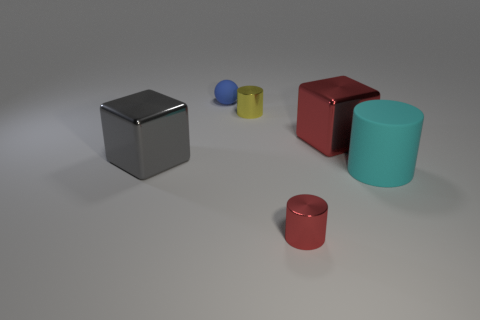There is a big block that is to the right of the tiny blue matte thing; are there any large rubber cylinders that are left of it?
Give a very brief answer. No. Are there any other things that are the same shape as the blue matte object?
Keep it short and to the point. No. There is another metal object that is the same shape as the large gray metal object; what is its color?
Provide a short and direct response. Red. What size is the blue thing?
Offer a very short reply. Small. Is the number of cyan things that are to the left of the large gray object less than the number of big cyan things?
Offer a terse response. Yes. Is the small blue thing made of the same material as the block left of the small yellow shiny cylinder?
Offer a very short reply. No. There is a big shiny block that is on the right side of the rubber thing behind the large cyan object; are there any metallic cylinders that are in front of it?
Keep it short and to the point. Yes. The other big object that is made of the same material as the big gray thing is what color?
Give a very brief answer. Red. What size is the cylinder that is behind the red shiny cylinder and left of the big rubber cylinder?
Ensure brevity in your answer.  Small. Are there fewer large things that are behind the big rubber cylinder than small yellow things that are behind the sphere?
Provide a succinct answer. No. 